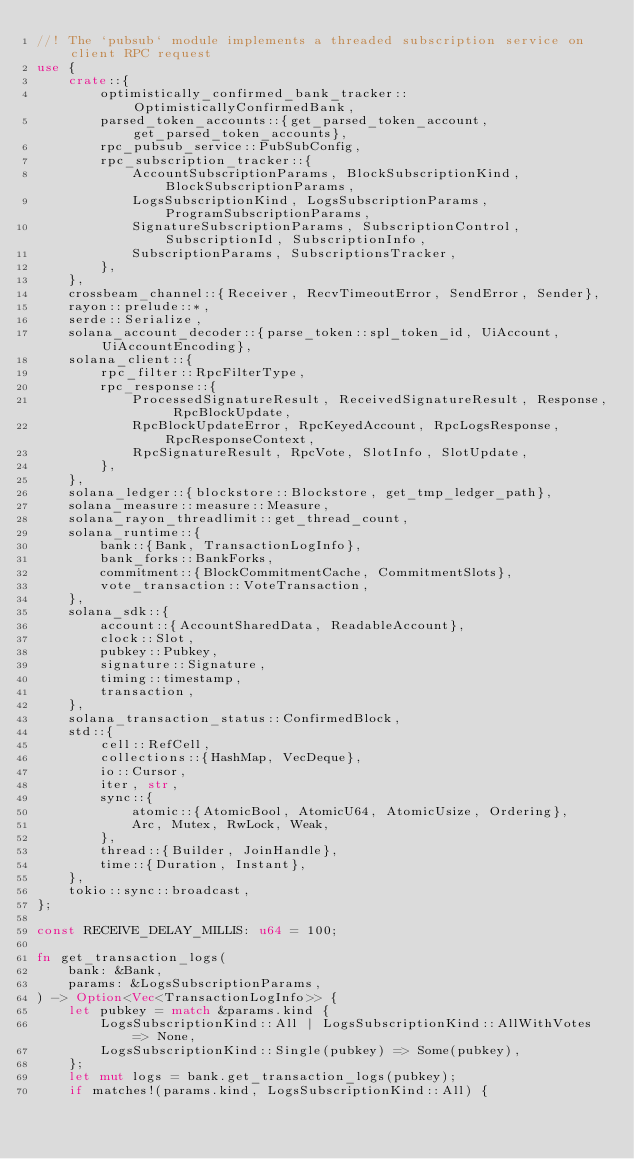<code> <loc_0><loc_0><loc_500><loc_500><_Rust_>//! The `pubsub` module implements a threaded subscription service on client RPC request
use {
    crate::{
        optimistically_confirmed_bank_tracker::OptimisticallyConfirmedBank,
        parsed_token_accounts::{get_parsed_token_account, get_parsed_token_accounts},
        rpc_pubsub_service::PubSubConfig,
        rpc_subscription_tracker::{
            AccountSubscriptionParams, BlockSubscriptionKind, BlockSubscriptionParams,
            LogsSubscriptionKind, LogsSubscriptionParams, ProgramSubscriptionParams,
            SignatureSubscriptionParams, SubscriptionControl, SubscriptionId, SubscriptionInfo,
            SubscriptionParams, SubscriptionsTracker,
        },
    },
    crossbeam_channel::{Receiver, RecvTimeoutError, SendError, Sender},
    rayon::prelude::*,
    serde::Serialize,
    solana_account_decoder::{parse_token::spl_token_id, UiAccount, UiAccountEncoding},
    solana_client::{
        rpc_filter::RpcFilterType,
        rpc_response::{
            ProcessedSignatureResult, ReceivedSignatureResult, Response, RpcBlockUpdate,
            RpcBlockUpdateError, RpcKeyedAccount, RpcLogsResponse, RpcResponseContext,
            RpcSignatureResult, RpcVote, SlotInfo, SlotUpdate,
        },
    },
    solana_ledger::{blockstore::Blockstore, get_tmp_ledger_path},
    solana_measure::measure::Measure,
    solana_rayon_threadlimit::get_thread_count,
    solana_runtime::{
        bank::{Bank, TransactionLogInfo},
        bank_forks::BankForks,
        commitment::{BlockCommitmentCache, CommitmentSlots},
        vote_transaction::VoteTransaction,
    },
    solana_sdk::{
        account::{AccountSharedData, ReadableAccount},
        clock::Slot,
        pubkey::Pubkey,
        signature::Signature,
        timing::timestamp,
        transaction,
    },
    solana_transaction_status::ConfirmedBlock,
    std::{
        cell::RefCell,
        collections::{HashMap, VecDeque},
        io::Cursor,
        iter, str,
        sync::{
            atomic::{AtomicBool, AtomicU64, AtomicUsize, Ordering},
            Arc, Mutex, RwLock, Weak,
        },
        thread::{Builder, JoinHandle},
        time::{Duration, Instant},
    },
    tokio::sync::broadcast,
};

const RECEIVE_DELAY_MILLIS: u64 = 100;

fn get_transaction_logs(
    bank: &Bank,
    params: &LogsSubscriptionParams,
) -> Option<Vec<TransactionLogInfo>> {
    let pubkey = match &params.kind {
        LogsSubscriptionKind::All | LogsSubscriptionKind::AllWithVotes => None,
        LogsSubscriptionKind::Single(pubkey) => Some(pubkey),
    };
    let mut logs = bank.get_transaction_logs(pubkey);
    if matches!(params.kind, LogsSubscriptionKind::All) {</code> 